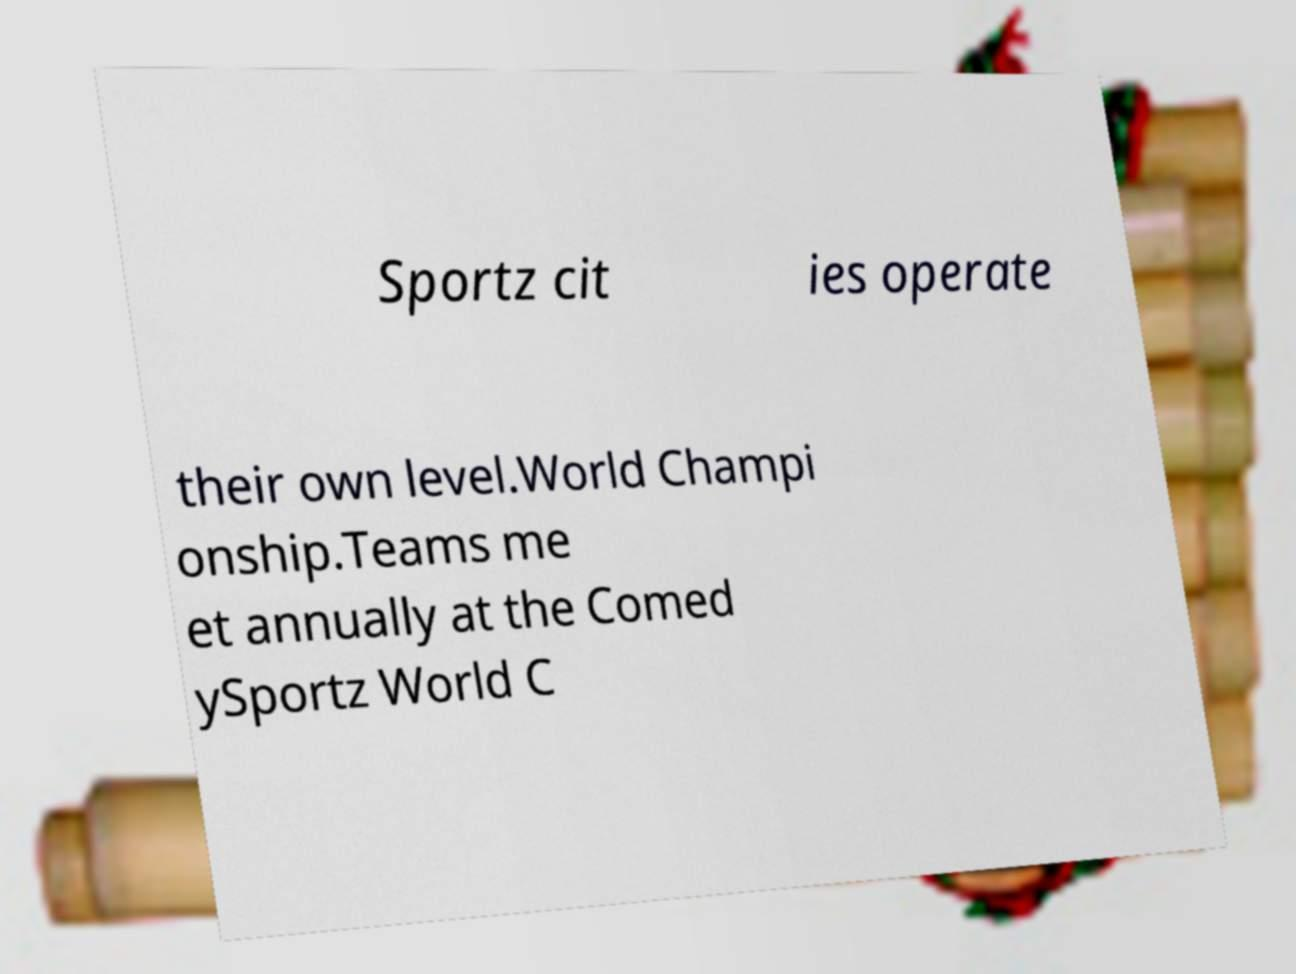Could you extract and type out the text from this image? Sportz cit ies operate their own level.World Champi onship.Teams me et annually at the Comed ySportz World C 